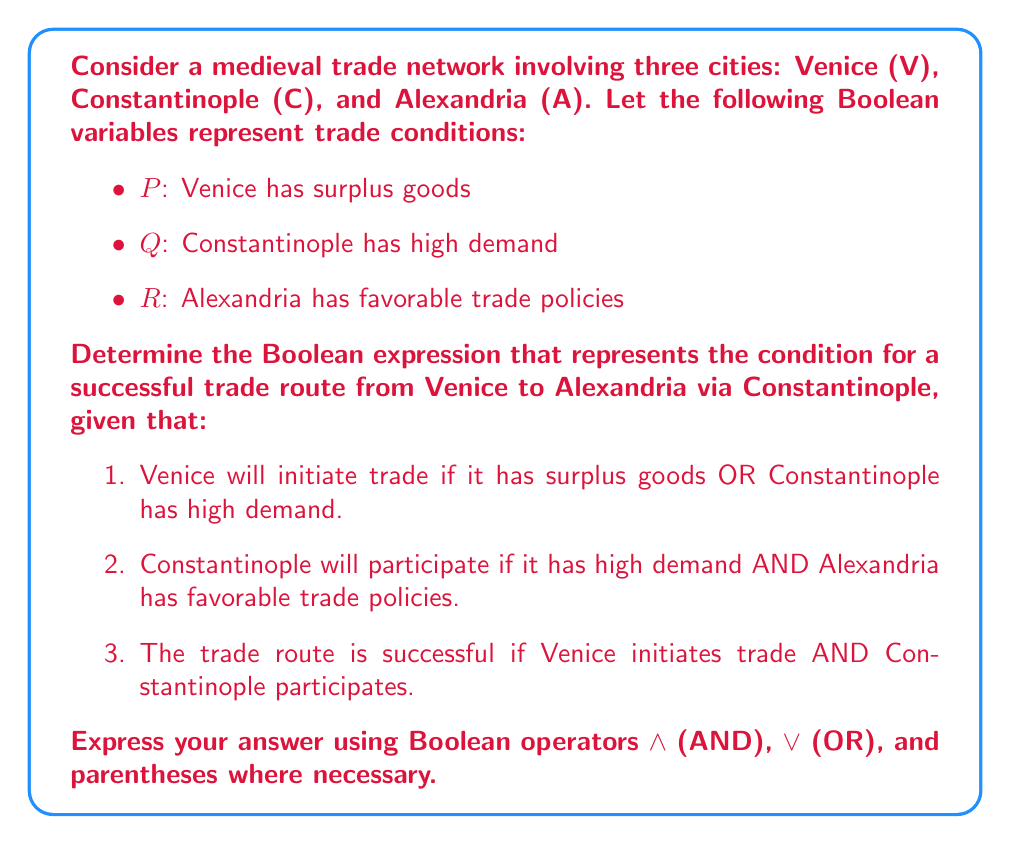Solve this math problem. Let's approach this step-by-step:

1. Venice initiating trade can be expressed as:
   $P \vee Q$

2. Constantinople participating can be expressed as:
   $Q \wedge R$

3. The successful trade route requires both conditions to be true, so we combine them with AND:
   $(P \vee Q) \wedge (Q \wedge R)$

4. We can simplify this expression using the distributive property of Boolean algebra:
   $(P \vee Q) \wedge Q \wedge R$

5. Using the absorption law $(A \vee B) \wedge B = B$, we can further simplify:
   $Q \wedge R \wedge (P \vee Q)$

6. Rearranging the terms (since AND is commutative):
   $(Q \wedge R) \wedge (P \vee Q)$

This final expression represents the condition for a successful trade route from Venice to Alexandria via Constantinople, taking into account all the given conditions.
Answer: $(Q \wedge R) \wedge (P \vee Q)$ 